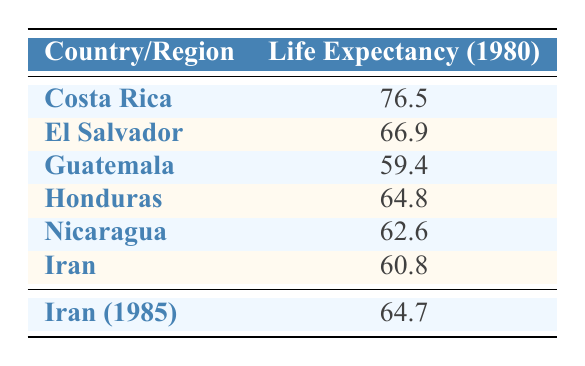What is the life expectancy of Costa Rica in 1980? According to the table, Costa Rica's life expectancy in 1980 is listed as 76.5.
Answer: 76.5 How does the life expectancy in El Salvador compare to that in Honduras in 1980? In the table, El Salvador has a life expectancy of 66.9 while Honduras has 64.8. Therefore, El Salvador has a higher life expectancy than Honduras by 2.1 years.
Answer: El Salvador is higher by 2.1 years What is the average life expectancy of the Central American countries listed for 1980? For the Central American countries (Costa Rica, El Salvador, Guatemala, Honduras, and Nicaragua), their life expectancies are 76.5, 66.9, 59.4, 64.8, and 62.6 respectively. The average is calculated by summing these values (76.5 + 66.9 + 59.4 + 64.8 + 62.6 = 330.2) and dividing by the number of countries (5), which gives us 330.2 / 5 = 66.04.
Answer: 66.04 Was there an increase in life expectancy in Iran from 1980 to 1985? The table shows that in 1980 the life expectancy in Iran was 60.8, and in 1985 it increased to 64.7. Therefore, there was indeed an increase of 3.9 years.
Answer: Yes, it increased How does the life expectancy of Nicaragua compare to the average of the life expectancies of Iran for the years provided? The life expectancy of Nicaragua in 1980 is 62.6, while the average for Iran, considering 1980 (60.8) and 1985 (64.7), is (60.8 + 64.7) / 2 = 62.75. Therefore, Nicaragua's life expectancy is less than the average of Iran's life expectancy by 0.15 years.
Answer: Nicaragua is lower by 0.15 years 